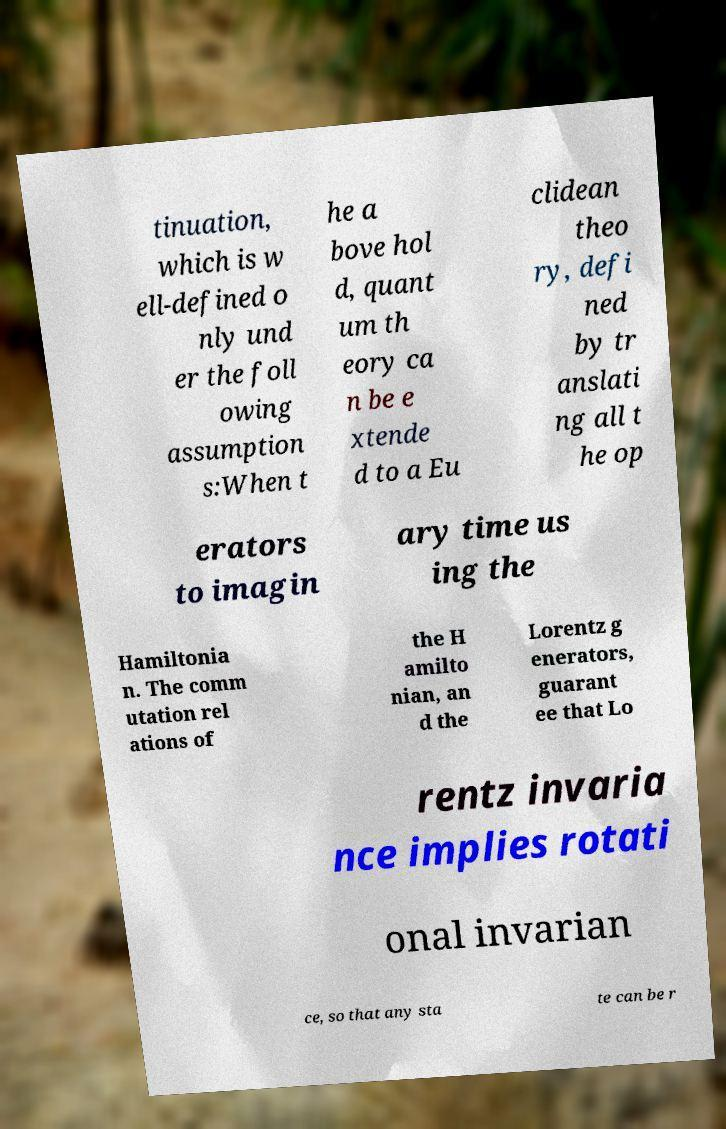For documentation purposes, I need the text within this image transcribed. Could you provide that? tinuation, which is w ell-defined o nly und er the foll owing assumption s:When t he a bove hol d, quant um th eory ca n be e xtende d to a Eu clidean theo ry, defi ned by tr anslati ng all t he op erators to imagin ary time us ing the Hamiltonia n. The comm utation rel ations of the H amilto nian, an d the Lorentz g enerators, guarant ee that Lo rentz invaria nce implies rotati onal invarian ce, so that any sta te can be r 